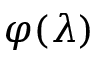<formula> <loc_0><loc_0><loc_500><loc_500>\varphi ( \lambda )</formula> 